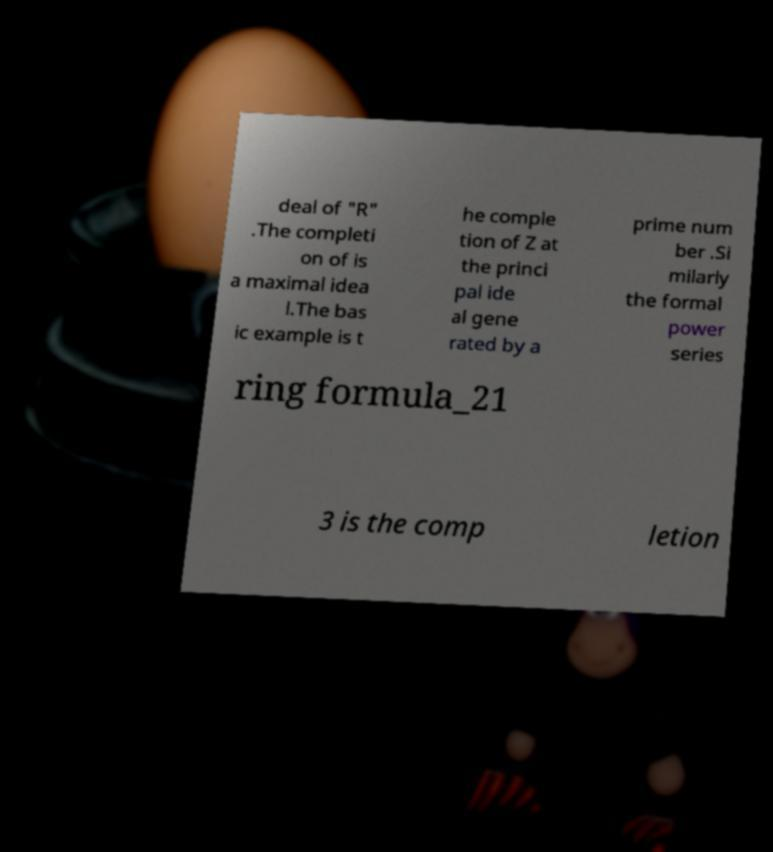There's text embedded in this image that I need extracted. Can you transcribe it verbatim? deal of "R" .The completi on of is a maximal idea l.The bas ic example is t he comple tion of Z at the princi pal ide al gene rated by a prime num ber .Si milarly the formal power series ring formula_21 3 is the comp letion 